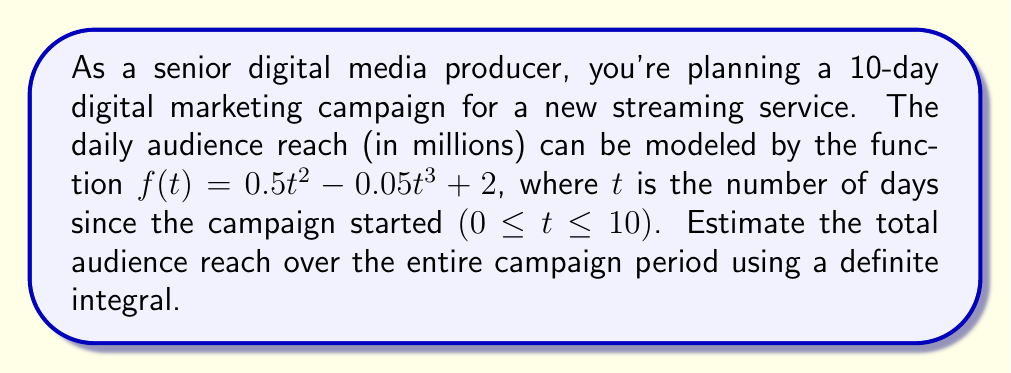Solve this math problem. To solve this problem, we need to follow these steps:

1) The function $f(t) = 0.5t^2 - 0.05t^3 + 2$ represents the daily audience reach in millions.

2) To find the total audience reach over the 10-day period, we need to integrate this function from $t=0$ to $t=10$.

3) The definite integral we need to calculate is:

   $$\int_0^{10} (0.5t^2 - 0.05t^3 + 2) dt$$

4) Let's integrate each term separately:

   $$\int 0.5t^2 dt = \frac{1}{3}(0.5)t^3 = \frac{1}{6}t^3$$
   $$\int -0.05t^3 dt = -\frac{1}{4}(0.05)t^4 = -\frac{1}{80}t^4$$
   $$\int 2 dt = 2t$$

5) Now, we have the indefinite integral:

   $$\frac{1}{6}t^3 - \frac{1}{80}t^4 + 2t + C$$

6) Applying the limits of integration:

   $$[\frac{1}{6}t^3 - \frac{1}{80}t^4 + 2t]_0^{10}$$

7) Calculating the values at $t=10$ and $t=0$:

   At $t=10$: $\frac{1}{6}(1000) - \frac{1}{80}(10000) + 2(10) = 166.67 - 125 + 20 = 61.67$
   At $t=0$: $0$

8) Subtracting:

   $61.67 - 0 = 61.67$

Therefore, the total estimated audience reach over the 10-day campaign is 61.67 million.
Answer: 61.67 million viewers 